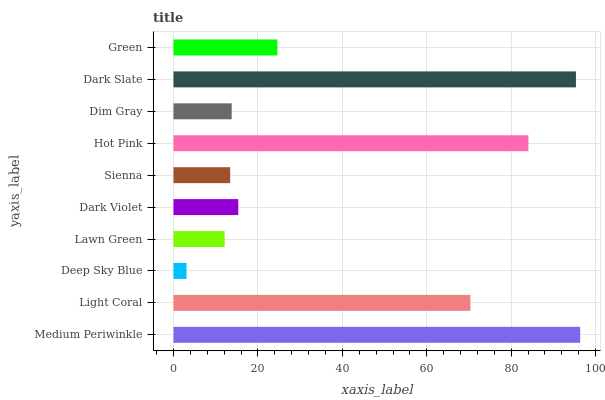Is Deep Sky Blue the minimum?
Answer yes or no. Yes. Is Medium Periwinkle the maximum?
Answer yes or no. Yes. Is Light Coral the minimum?
Answer yes or no. No. Is Light Coral the maximum?
Answer yes or no. No. Is Medium Periwinkle greater than Light Coral?
Answer yes or no. Yes. Is Light Coral less than Medium Periwinkle?
Answer yes or no. Yes. Is Light Coral greater than Medium Periwinkle?
Answer yes or no. No. Is Medium Periwinkle less than Light Coral?
Answer yes or no. No. Is Green the high median?
Answer yes or no. Yes. Is Dark Violet the low median?
Answer yes or no. Yes. Is Dark Slate the high median?
Answer yes or no. No. Is Hot Pink the low median?
Answer yes or no. No. 